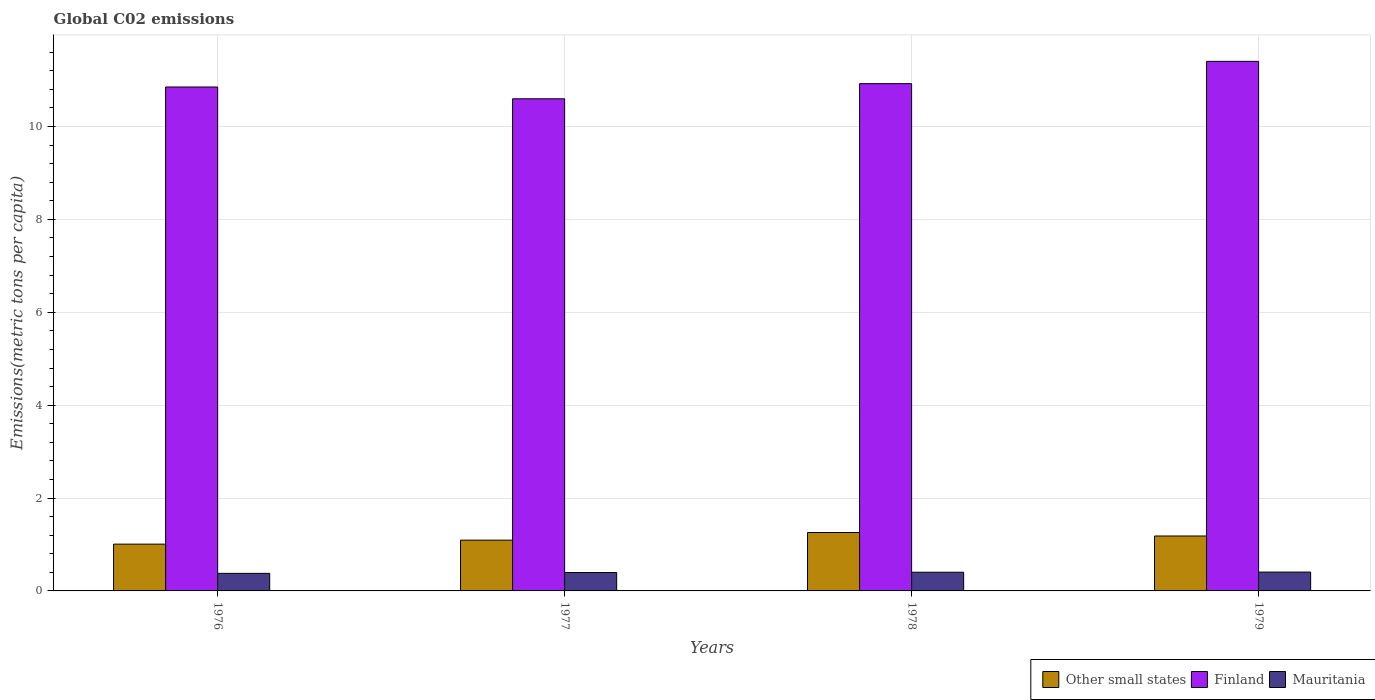How many different coloured bars are there?
Make the answer very short. 3. How many groups of bars are there?
Keep it short and to the point. 4. Are the number of bars per tick equal to the number of legend labels?
Provide a succinct answer. Yes. What is the label of the 4th group of bars from the left?
Provide a short and direct response. 1979. What is the amount of CO2 emitted in in Other small states in 1976?
Your answer should be very brief. 1.01. Across all years, what is the maximum amount of CO2 emitted in in Other small states?
Your response must be concise. 1.26. Across all years, what is the minimum amount of CO2 emitted in in Other small states?
Your response must be concise. 1.01. In which year was the amount of CO2 emitted in in Mauritania maximum?
Your answer should be compact. 1979. In which year was the amount of CO2 emitted in in Finland minimum?
Ensure brevity in your answer.  1977. What is the total amount of CO2 emitted in in Finland in the graph?
Provide a short and direct response. 43.78. What is the difference between the amount of CO2 emitted in in Other small states in 1976 and that in 1978?
Keep it short and to the point. -0.25. What is the difference between the amount of CO2 emitted in in Mauritania in 1976 and the amount of CO2 emitted in in Other small states in 1979?
Provide a succinct answer. -0.8. What is the average amount of CO2 emitted in in Finland per year?
Provide a succinct answer. 10.94. In the year 1977, what is the difference between the amount of CO2 emitted in in Other small states and amount of CO2 emitted in in Mauritania?
Provide a short and direct response. 0.7. What is the ratio of the amount of CO2 emitted in in Other small states in 1978 to that in 1979?
Give a very brief answer. 1.06. Is the amount of CO2 emitted in in Other small states in 1976 less than that in 1978?
Offer a terse response. Yes. Is the difference between the amount of CO2 emitted in in Other small states in 1978 and 1979 greater than the difference between the amount of CO2 emitted in in Mauritania in 1978 and 1979?
Your response must be concise. Yes. What is the difference between the highest and the second highest amount of CO2 emitted in in Finland?
Your response must be concise. 0.48. What is the difference between the highest and the lowest amount of CO2 emitted in in Mauritania?
Offer a terse response. 0.03. Is the sum of the amount of CO2 emitted in in Mauritania in 1976 and 1978 greater than the maximum amount of CO2 emitted in in Finland across all years?
Provide a short and direct response. No. What does the 2nd bar from the left in 1978 represents?
Your response must be concise. Finland. Is it the case that in every year, the sum of the amount of CO2 emitted in in Mauritania and amount of CO2 emitted in in Finland is greater than the amount of CO2 emitted in in Other small states?
Your answer should be compact. Yes. How many bars are there?
Ensure brevity in your answer.  12. How many years are there in the graph?
Your response must be concise. 4. What is the difference between two consecutive major ticks on the Y-axis?
Give a very brief answer. 2. How are the legend labels stacked?
Offer a very short reply. Horizontal. What is the title of the graph?
Make the answer very short. Global C02 emissions. What is the label or title of the Y-axis?
Offer a very short reply. Emissions(metric tons per capita). What is the Emissions(metric tons per capita) of Other small states in 1976?
Give a very brief answer. 1.01. What is the Emissions(metric tons per capita) of Finland in 1976?
Make the answer very short. 10.85. What is the Emissions(metric tons per capita) in Mauritania in 1976?
Your answer should be compact. 0.38. What is the Emissions(metric tons per capita) of Other small states in 1977?
Provide a succinct answer. 1.09. What is the Emissions(metric tons per capita) in Finland in 1977?
Your response must be concise. 10.6. What is the Emissions(metric tons per capita) of Mauritania in 1977?
Offer a terse response. 0.4. What is the Emissions(metric tons per capita) in Other small states in 1978?
Offer a terse response. 1.26. What is the Emissions(metric tons per capita) of Finland in 1978?
Give a very brief answer. 10.92. What is the Emissions(metric tons per capita) of Mauritania in 1978?
Make the answer very short. 0.4. What is the Emissions(metric tons per capita) in Other small states in 1979?
Make the answer very short. 1.18. What is the Emissions(metric tons per capita) of Finland in 1979?
Ensure brevity in your answer.  11.4. What is the Emissions(metric tons per capita) of Mauritania in 1979?
Make the answer very short. 0.41. Across all years, what is the maximum Emissions(metric tons per capita) of Other small states?
Offer a very short reply. 1.26. Across all years, what is the maximum Emissions(metric tons per capita) in Finland?
Your answer should be very brief. 11.4. Across all years, what is the maximum Emissions(metric tons per capita) in Mauritania?
Offer a very short reply. 0.41. Across all years, what is the minimum Emissions(metric tons per capita) in Other small states?
Ensure brevity in your answer.  1.01. Across all years, what is the minimum Emissions(metric tons per capita) of Finland?
Your answer should be compact. 10.6. Across all years, what is the minimum Emissions(metric tons per capita) of Mauritania?
Offer a very short reply. 0.38. What is the total Emissions(metric tons per capita) in Other small states in the graph?
Your response must be concise. 4.54. What is the total Emissions(metric tons per capita) of Finland in the graph?
Provide a succinct answer. 43.78. What is the total Emissions(metric tons per capita) of Mauritania in the graph?
Your answer should be very brief. 1.58. What is the difference between the Emissions(metric tons per capita) of Other small states in 1976 and that in 1977?
Make the answer very short. -0.09. What is the difference between the Emissions(metric tons per capita) in Finland in 1976 and that in 1977?
Keep it short and to the point. 0.25. What is the difference between the Emissions(metric tons per capita) in Mauritania in 1976 and that in 1977?
Keep it short and to the point. -0.02. What is the difference between the Emissions(metric tons per capita) of Other small states in 1976 and that in 1978?
Ensure brevity in your answer.  -0.25. What is the difference between the Emissions(metric tons per capita) of Finland in 1976 and that in 1978?
Offer a terse response. -0.07. What is the difference between the Emissions(metric tons per capita) of Mauritania in 1976 and that in 1978?
Your response must be concise. -0.02. What is the difference between the Emissions(metric tons per capita) of Other small states in 1976 and that in 1979?
Your answer should be very brief. -0.18. What is the difference between the Emissions(metric tons per capita) of Finland in 1976 and that in 1979?
Ensure brevity in your answer.  -0.55. What is the difference between the Emissions(metric tons per capita) in Mauritania in 1976 and that in 1979?
Give a very brief answer. -0.03. What is the difference between the Emissions(metric tons per capita) in Other small states in 1977 and that in 1978?
Your response must be concise. -0.16. What is the difference between the Emissions(metric tons per capita) of Finland in 1977 and that in 1978?
Keep it short and to the point. -0.33. What is the difference between the Emissions(metric tons per capita) of Mauritania in 1977 and that in 1978?
Ensure brevity in your answer.  -0.01. What is the difference between the Emissions(metric tons per capita) of Other small states in 1977 and that in 1979?
Provide a short and direct response. -0.09. What is the difference between the Emissions(metric tons per capita) of Finland in 1977 and that in 1979?
Provide a succinct answer. -0.81. What is the difference between the Emissions(metric tons per capita) of Mauritania in 1977 and that in 1979?
Give a very brief answer. -0.01. What is the difference between the Emissions(metric tons per capita) of Other small states in 1978 and that in 1979?
Provide a short and direct response. 0.08. What is the difference between the Emissions(metric tons per capita) of Finland in 1978 and that in 1979?
Ensure brevity in your answer.  -0.48. What is the difference between the Emissions(metric tons per capita) of Mauritania in 1978 and that in 1979?
Your answer should be compact. -0. What is the difference between the Emissions(metric tons per capita) of Other small states in 1976 and the Emissions(metric tons per capita) of Finland in 1977?
Keep it short and to the point. -9.59. What is the difference between the Emissions(metric tons per capita) of Other small states in 1976 and the Emissions(metric tons per capita) of Mauritania in 1977?
Your response must be concise. 0.61. What is the difference between the Emissions(metric tons per capita) in Finland in 1976 and the Emissions(metric tons per capita) in Mauritania in 1977?
Your answer should be compact. 10.46. What is the difference between the Emissions(metric tons per capita) of Other small states in 1976 and the Emissions(metric tons per capita) of Finland in 1978?
Your response must be concise. -9.92. What is the difference between the Emissions(metric tons per capita) of Other small states in 1976 and the Emissions(metric tons per capita) of Mauritania in 1978?
Make the answer very short. 0.61. What is the difference between the Emissions(metric tons per capita) of Finland in 1976 and the Emissions(metric tons per capita) of Mauritania in 1978?
Keep it short and to the point. 10.45. What is the difference between the Emissions(metric tons per capita) of Other small states in 1976 and the Emissions(metric tons per capita) of Finland in 1979?
Keep it short and to the point. -10.4. What is the difference between the Emissions(metric tons per capita) of Other small states in 1976 and the Emissions(metric tons per capita) of Mauritania in 1979?
Your answer should be very brief. 0.6. What is the difference between the Emissions(metric tons per capita) in Finland in 1976 and the Emissions(metric tons per capita) in Mauritania in 1979?
Provide a succinct answer. 10.45. What is the difference between the Emissions(metric tons per capita) of Other small states in 1977 and the Emissions(metric tons per capita) of Finland in 1978?
Ensure brevity in your answer.  -9.83. What is the difference between the Emissions(metric tons per capita) in Other small states in 1977 and the Emissions(metric tons per capita) in Mauritania in 1978?
Offer a very short reply. 0.69. What is the difference between the Emissions(metric tons per capita) of Finland in 1977 and the Emissions(metric tons per capita) of Mauritania in 1978?
Offer a very short reply. 10.19. What is the difference between the Emissions(metric tons per capita) of Other small states in 1977 and the Emissions(metric tons per capita) of Finland in 1979?
Keep it short and to the point. -10.31. What is the difference between the Emissions(metric tons per capita) in Other small states in 1977 and the Emissions(metric tons per capita) in Mauritania in 1979?
Keep it short and to the point. 0.69. What is the difference between the Emissions(metric tons per capita) in Finland in 1977 and the Emissions(metric tons per capita) in Mauritania in 1979?
Give a very brief answer. 10.19. What is the difference between the Emissions(metric tons per capita) of Other small states in 1978 and the Emissions(metric tons per capita) of Finland in 1979?
Ensure brevity in your answer.  -10.15. What is the difference between the Emissions(metric tons per capita) of Other small states in 1978 and the Emissions(metric tons per capita) of Mauritania in 1979?
Offer a terse response. 0.85. What is the difference between the Emissions(metric tons per capita) of Finland in 1978 and the Emissions(metric tons per capita) of Mauritania in 1979?
Your answer should be very brief. 10.52. What is the average Emissions(metric tons per capita) of Other small states per year?
Provide a succinct answer. 1.14. What is the average Emissions(metric tons per capita) of Finland per year?
Offer a terse response. 10.94. What is the average Emissions(metric tons per capita) of Mauritania per year?
Provide a short and direct response. 0.4. In the year 1976, what is the difference between the Emissions(metric tons per capita) of Other small states and Emissions(metric tons per capita) of Finland?
Your answer should be very brief. -9.84. In the year 1976, what is the difference between the Emissions(metric tons per capita) in Other small states and Emissions(metric tons per capita) in Mauritania?
Your answer should be very brief. 0.63. In the year 1976, what is the difference between the Emissions(metric tons per capita) of Finland and Emissions(metric tons per capita) of Mauritania?
Ensure brevity in your answer.  10.47. In the year 1977, what is the difference between the Emissions(metric tons per capita) of Other small states and Emissions(metric tons per capita) of Finland?
Offer a terse response. -9.5. In the year 1977, what is the difference between the Emissions(metric tons per capita) in Other small states and Emissions(metric tons per capita) in Mauritania?
Provide a succinct answer. 0.7. In the year 1977, what is the difference between the Emissions(metric tons per capita) of Finland and Emissions(metric tons per capita) of Mauritania?
Give a very brief answer. 10.2. In the year 1978, what is the difference between the Emissions(metric tons per capita) of Other small states and Emissions(metric tons per capita) of Finland?
Provide a short and direct response. -9.67. In the year 1978, what is the difference between the Emissions(metric tons per capita) of Other small states and Emissions(metric tons per capita) of Mauritania?
Offer a very short reply. 0.86. In the year 1978, what is the difference between the Emissions(metric tons per capita) of Finland and Emissions(metric tons per capita) of Mauritania?
Your answer should be very brief. 10.52. In the year 1979, what is the difference between the Emissions(metric tons per capita) of Other small states and Emissions(metric tons per capita) of Finland?
Keep it short and to the point. -10.22. In the year 1979, what is the difference between the Emissions(metric tons per capita) in Other small states and Emissions(metric tons per capita) in Mauritania?
Give a very brief answer. 0.78. In the year 1979, what is the difference between the Emissions(metric tons per capita) in Finland and Emissions(metric tons per capita) in Mauritania?
Provide a short and direct response. 11. What is the ratio of the Emissions(metric tons per capita) of Other small states in 1976 to that in 1977?
Make the answer very short. 0.92. What is the ratio of the Emissions(metric tons per capita) of Mauritania in 1976 to that in 1977?
Offer a terse response. 0.95. What is the ratio of the Emissions(metric tons per capita) in Other small states in 1976 to that in 1978?
Ensure brevity in your answer.  0.8. What is the ratio of the Emissions(metric tons per capita) of Mauritania in 1976 to that in 1978?
Offer a terse response. 0.94. What is the ratio of the Emissions(metric tons per capita) of Other small states in 1976 to that in 1979?
Your response must be concise. 0.85. What is the ratio of the Emissions(metric tons per capita) in Finland in 1976 to that in 1979?
Keep it short and to the point. 0.95. What is the ratio of the Emissions(metric tons per capita) in Mauritania in 1976 to that in 1979?
Your answer should be very brief. 0.93. What is the ratio of the Emissions(metric tons per capita) of Other small states in 1977 to that in 1978?
Your response must be concise. 0.87. What is the ratio of the Emissions(metric tons per capita) in Finland in 1977 to that in 1978?
Keep it short and to the point. 0.97. What is the ratio of the Emissions(metric tons per capita) in Mauritania in 1977 to that in 1978?
Keep it short and to the point. 0.98. What is the ratio of the Emissions(metric tons per capita) of Other small states in 1977 to that in 1979?
Your answer should be very brief. 0.92. What is the ratio of the Emissions(metric tons per capita) of Finland in 1977 to that in 1979?
Your answer should be very brief. 0.93. What is the ratio of the Emissions(metric tons per capita) of Mauritania in 1977 to that in 1979?
Offer a terse response. 0.98. What is the ratio of the Emissions(metric tons per capita) of Other small states in 1978 to that in 1979?
Provide a short and direct response. 1.06. What is the ratio of the Emissions(metric tons per capita) of Finland in 1978 to that in 1979?
Offer a very short reply. 0.96. What is the difference between the highest and the second highest Emissions(metric tons per capita) of Other small states?
Your answer should be very brief. 0.08. What is the difference between the highest and the second highest Emissions(metric tons per capita) of Finland?
Your answer should be very brief. 0.48. What is the difference between the highest and the second highest Emissions(metric tons per capita) in Mauritania?
Make the answer very short. 0. What is the difference between the highest and the lowest Emissions(metric tons per capita) of Other small states?
Provide a succinct answer. 0.25. What is the difference between the highest and the lowest Emissions(metric tons per capita) of Finland?
Offer a terse response. 0.81. What is the difference between the highest and the lowest Emissions(metric tons per capita) in Mauritania?
Give a very brief answer. 0.03. 